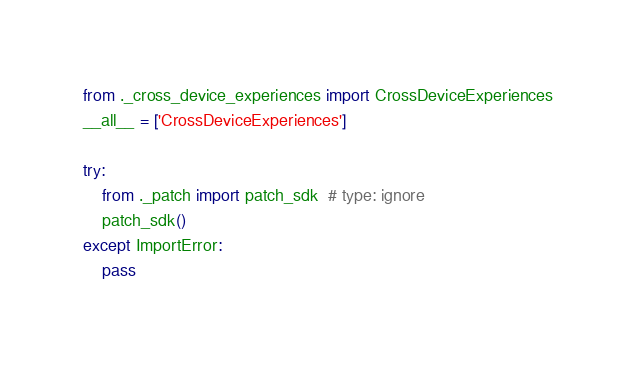<code> <loc_0><loc_0><loc_500><loc_500><_Python_>
from ._cross_device_experiences import CrossDeviceExperiences
__all__ = ['CrossDeviceExperiences']

try:
    from ._patch import patch_sdk  # type: ignore
    patch_sdk()
except ImportError:
    pass
</code> 